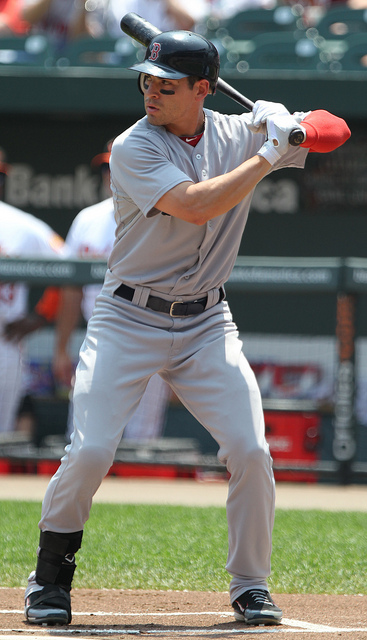Identify the text displayed in this image. B Bank 